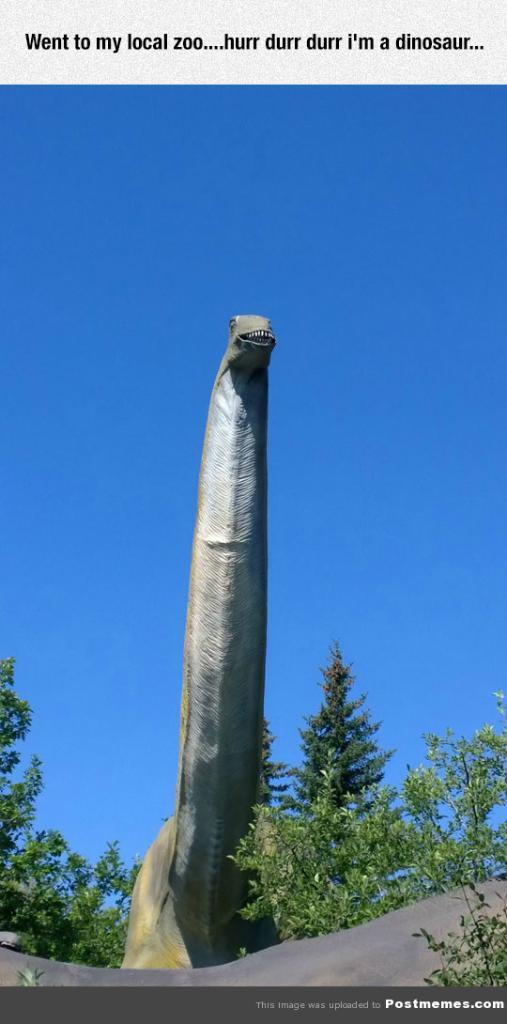What type of living creature is in the image? There is an animal in the image. What natural elements can be seen in the image? There are trees and the sky in the image. What is the color of the sky in the image? The sky is blue in the image. Are there any written words in the image? Yes, there are words written in the image. Is there a kite flying in the blue sky in the image? There is no kite visible in the image; only the animal, trees, and written words are present. 